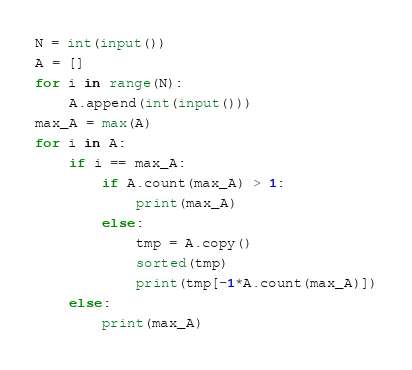Convert code to text. <code><loc_0><loc_0><loc_500><loc_500><_Python_>N = int(input())
A = []
for i in range(N):
    A.append(int(input()))
max_A = max(A)
for i in A:
    if i == max_A:
        if A.count(max_A) > 1:
            print(max_A)
        else:
            tmp = A.copy()
            sorted(tmp)
            print(tmp[-1*A.count(max_A)])
    else:
        print(max_A)</code> 